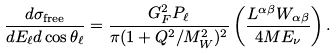<formula> <loc_0><loc_0><loc_500><loc_500>\frac { d \sigma _ { \text {free} } } { d E _ { \ell } d \cos \theta _ { \ell } } = \frac { G _ { F } ^ { 2 } P _ { \ell } } { \pi ( 1 + Q ^ { 2 } / M _ { W } ^ { 2 } ) ^ { 2 } } \left ( \frac { L ^ { \alpha \beta } W _ { \alpha \beta } } { 4 M E _ { \nu } } \right ) .</formula> 